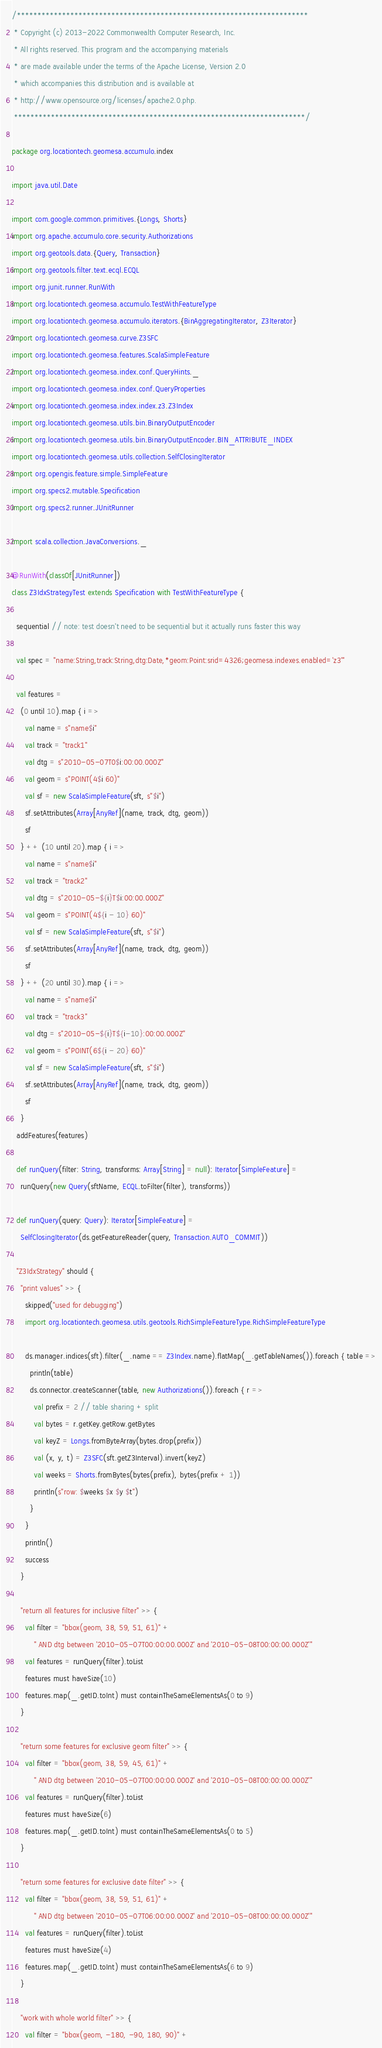Convert code to text. <code><loc_0><loc_0><loc_500><loc_500><_Scala_>/***********************************************************************
 * Copyright (c) 2013-2022 Commonwealth Computer Research, Inc.
 * All rights reserved. This program and the accompanying materials
 * are made available under the terms of the Apache License, Version 2.0
 * which accompanies this distribution and is available at
 * http://www.opensource.org/licenses/apache2.0.php.
 ***********************************************************************/

package org.locationtech.geomesa.accumulo.index

import java.util.Date

import com.google.common.primitives.{Longs, Shorts}
import org.apache.accumulo.core.security.Authorizations
import org.geotools.data.{Query, Transaction}
import org.geotools.filter.text.ecql.ECQL
import org.junit.runner.RunWith
import org.locationtech.geomesa.accumulo.TestWithFeatureType
import org.locationtech.geomesa.accumulo.iterators.{BinAggregatingIterator, Z3Iterator}
import org.locationtech.geomesa.curve.Z3SFC
import org.locationtech.geomesa.features.ScalaSimpleFeature
import org.locationtech.geomesa.index.conf.QueryHints._
import org.locationtech.geomesa.index.conf.QueryProperties
import org.locationtech.geomesa.index.index.z3.Z3Index
import org.locationtech.geomesa.utils.bin.BinaryOutputEncoder
import org.locationtech.geomesa.utils.bin.BinaryOutputEncoder.BIN_ATTRIBUTE_INDEX
import org.locationtech.geomesa.utils.collection.SelfClosingIterator
import org.opengis.feature.simple.SimpleFeature
import org.specs2.mutable.Specification
import org.specs2.runner.JUnitRunner

import scala.collection.JavaConversions._

@RunWith(classOf[JUnitRunner])
class Z3IdxStrategyTest extends Specification with TestWithFeatureType {

  sequential // note: test doesn't need to be sequential but it actually runs faster this way

  val spec = "name:String,track:String,dtg:Date,*geom:Point:srid=4326;geomesa.indexes.enabled='z3'"

  val features =
    (0 until 10).map { i =>
      val name = s"name$i"
      val track = "track1"
      val dtg = s"2010-05-07T0$i:00:00.000Z"
      val geom = s"POINT(4$i 60)"
      val sf = new ScalaSimpleFeature(sft, s"$i")
      sf.setAttributes(Array[AnyRef](name, track, dtg, geom))
      sf
    } ++ (10 until 20).map { i =>
      val name = s"name$i"
      val track = "track2"
      val dtg = s"2010-05-${i}T$i:00:00.000Z"
      val geom = s"POINT(4${i - 10} 60)"
      val sf = new ScalaSimpleFeature(sft, s"$i")
      sf.setAttributes(Array[AnyRef](name, track, dtg, geom))
      sf
    } ++ (20 until 30).map { i =>
      val name = s"name$i"
      val track = "track3"
      val dtg = s"2010-05-${i}T${i-10}:00:00.000Z"
      val geom = s"POINT(6${i - 20} 60)"
      val sf = new ScalaSimpleFeature(sft, s"$i")
      sf.setAttributes(Array[AnyRef](name, track, dtg, geom))
      sf
    }
  addFeatures(features)

  def runQuery(filter: String, transforms: Array[String] = null): Iterator[SimpleFeature] =
    runQuery(new Query(sftName, ECQL.toFilter(filter), transforms))

  def runQuery(query: Query): Iterator[SimpleFeature] =
    SelfClosingIterator(ds.getFeatureReader(query, Transaction.AUTO_COMMIT))

  "Z3IdxStrategy" should {
    "print values" >> {
      skipped("used for debugging")
      import org.locationtech.geomesa.utils.geotools.RichSimpleFeatureType.RichSimpleFeatureType

      ds.manager.indices(sft).filter(_.name == Z3Index.name).flatMap(_.getTableNames()).foreach { table =>
        println(table)
        ds.connector.createScanner(table, new Authorizations()).foreach { r =>
          val prefix = 2 // table sharing + split
          val bytes = r.getKey.getRow.getBytes
          val keyZ = Longs.fromByteArray(bytes.drop(prefix))
          val (x, y, t) = Z3SFC(sft.getZ3Interval).invert(keyZ)
          val weeks = Shorts.fromBytes(bytes(prefix), bytes(prefix + 1))
          println(s"row: $weeks $x $y $t")
        }
      }
      println()
      success
    }

    "return all features for inclusive filter" >> {
      val filter = "bbox(geom, 38, 59, 51, 61)" +
          " AND dtg between '2010-05-07T00:00:00.000Z' and '2010-05-08T00:00:00.000Z'"
      val features = runQuery(filter).toList
      features must haveSize(10)
      features.map(_.getID.toInt) must containTheSameElementsAs(0 to 9)
    }

    "return some features for exclusive geom filter" >> {
      val filter = "bbox(geom, 38, 59, 45, 61)" +
          " AND dtg between '2010-05-07T00:00:00.000Z' and '2010-05-08T00:00:00.000Z'"
      val features = runQuery(filter).toList
      features must haveSize(6)
      features.map(_.getID.toInt) must containTheSameElementsAs(0 to 5)
    }

    "return some features for exclusive date filter" >> {
      val filter = "bbox(geom, 38, 59, 51, 61)" +
          " AND dtg between '2010-05-07T06:00:00.000Z' and '2010-05-08T00:00:00.000Z'"
      val features = runQuery(filter).toList
      features must haveSize(4)
      features.map(_.getID.toInt) must containTheSameElementsAs(6 to 9)
    }

    "work with whole world filter" >> {
      val filter = "bbox(geom, -180, -90, 180, 90)" +</code> 